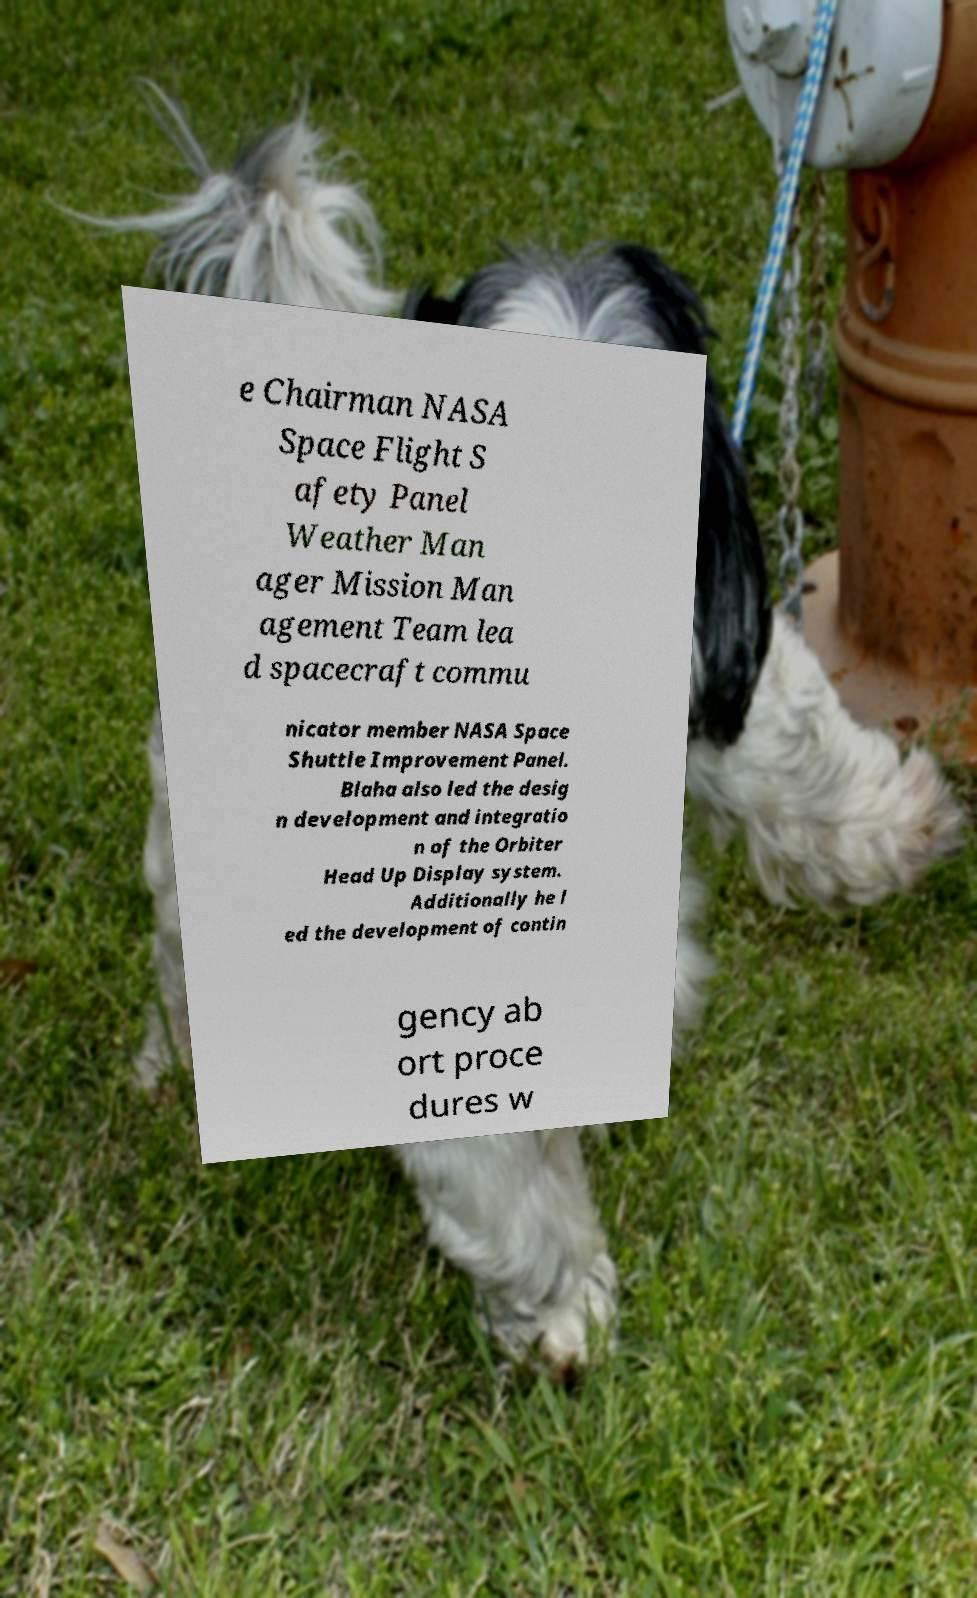For documentation purposes, I need the text within this image transcribed. Could you provide that? e Chairman NASA Space Flight S afety Panel Weather Man ager Mission Man agement Team lea d spacecraft commu nicator member NASA Space Shuttle Improvement Panel. Blaha also led the desig n development and integratio n of the Orbiter Head Up Display system. Additionally he l ed the development of contin gency ab ort proce dures w 